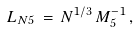<formula> <loc_0><loc_0><loc_500><loc_500>L _ { N 5 } \, = \, N ^ { 1 / 3 } \, M _ { 5 } ^ { - 1 } \, ,</formula> 